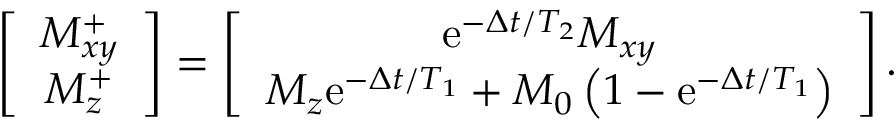Convert formula to latex. <formula><loc_0><loc_0><loc_500><loc_500>\begin{array} { r } { \left [ \begin{array} { c } { M _ { x y } ^ { + } } \\ { M _ { z } ^ { + } } \end{array} \right ] = \left [ \begin{array} { c } { e ^ { - \Delta t / T _ { 2 } } M _ { x y } } \\ { M _ { z } e ^ { - \Delta t / T _ { 1 } } + M _ { 0 } \left ( 1 - e ^ { - \Delta t / T _ { 1 } } \right ) } \end{array} \right ] . } \end{array}</formula> 